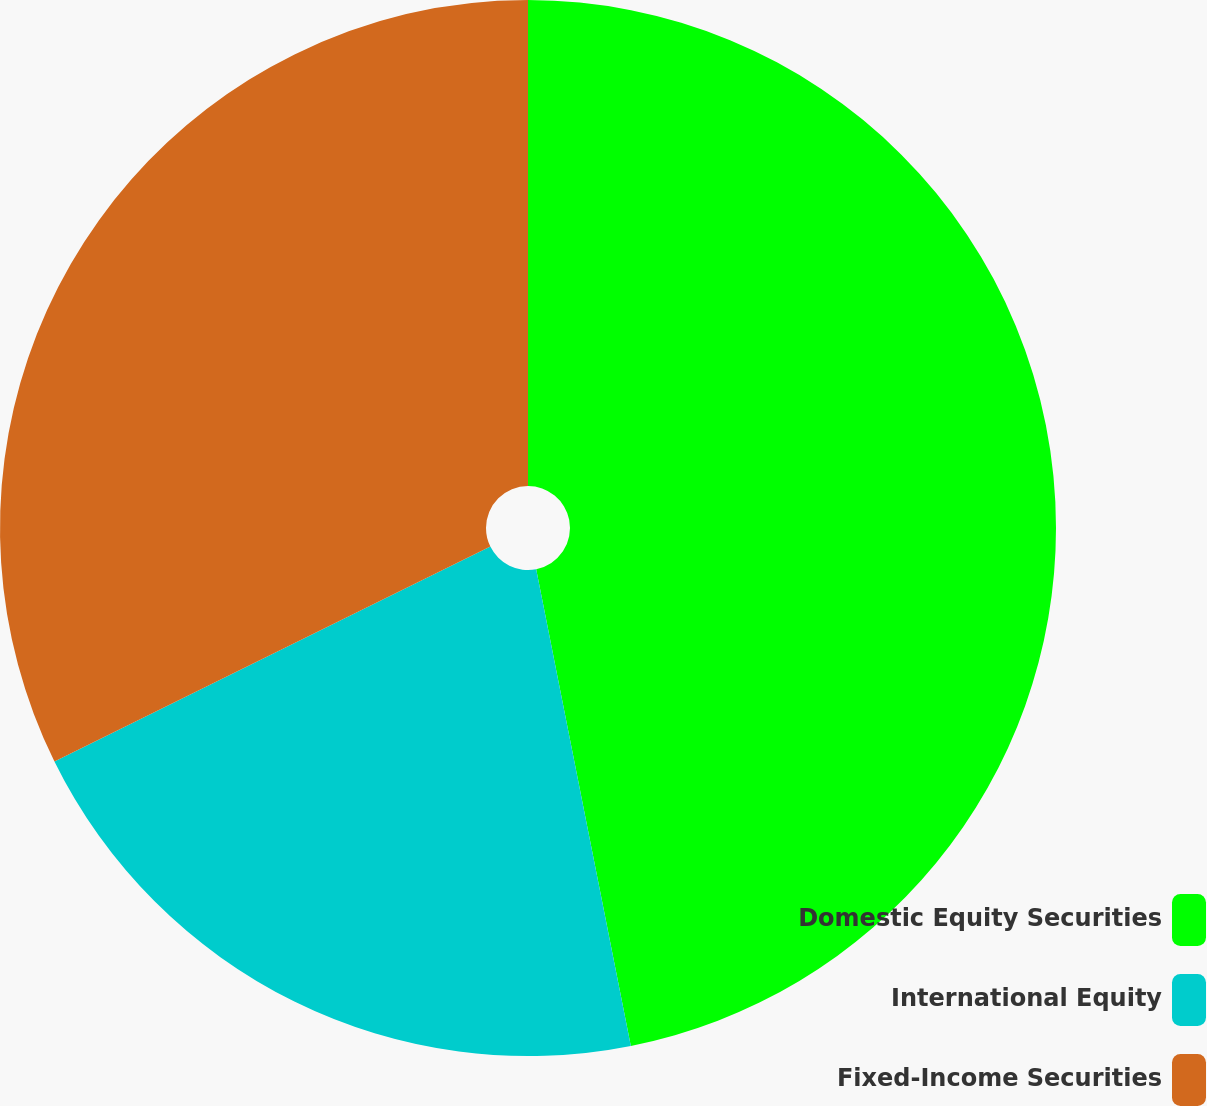<chart> <loc_0><loc_0><loc_500><loc_500><pie_chart><fcel>Domestic Equity Securities<fcel>International Equity<fcel>Fixed-Income Securities<nl><fcel>46.88%<fcel>20.83%<fcel>32.29%<nl></chart> 